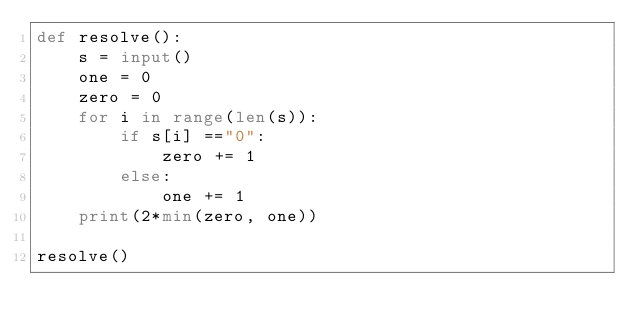Convert code to text. <code><loc_0><loc_0><loc_500><loc_500><_Python_>def resolve():
    s = input()
    one = 0
    zero = 0
    for i in range(len(s)):
        if s[i] =="0":
            zero += 1
        else:
            one += 1
    print(2*min(zero, one))

resolve()</code> 